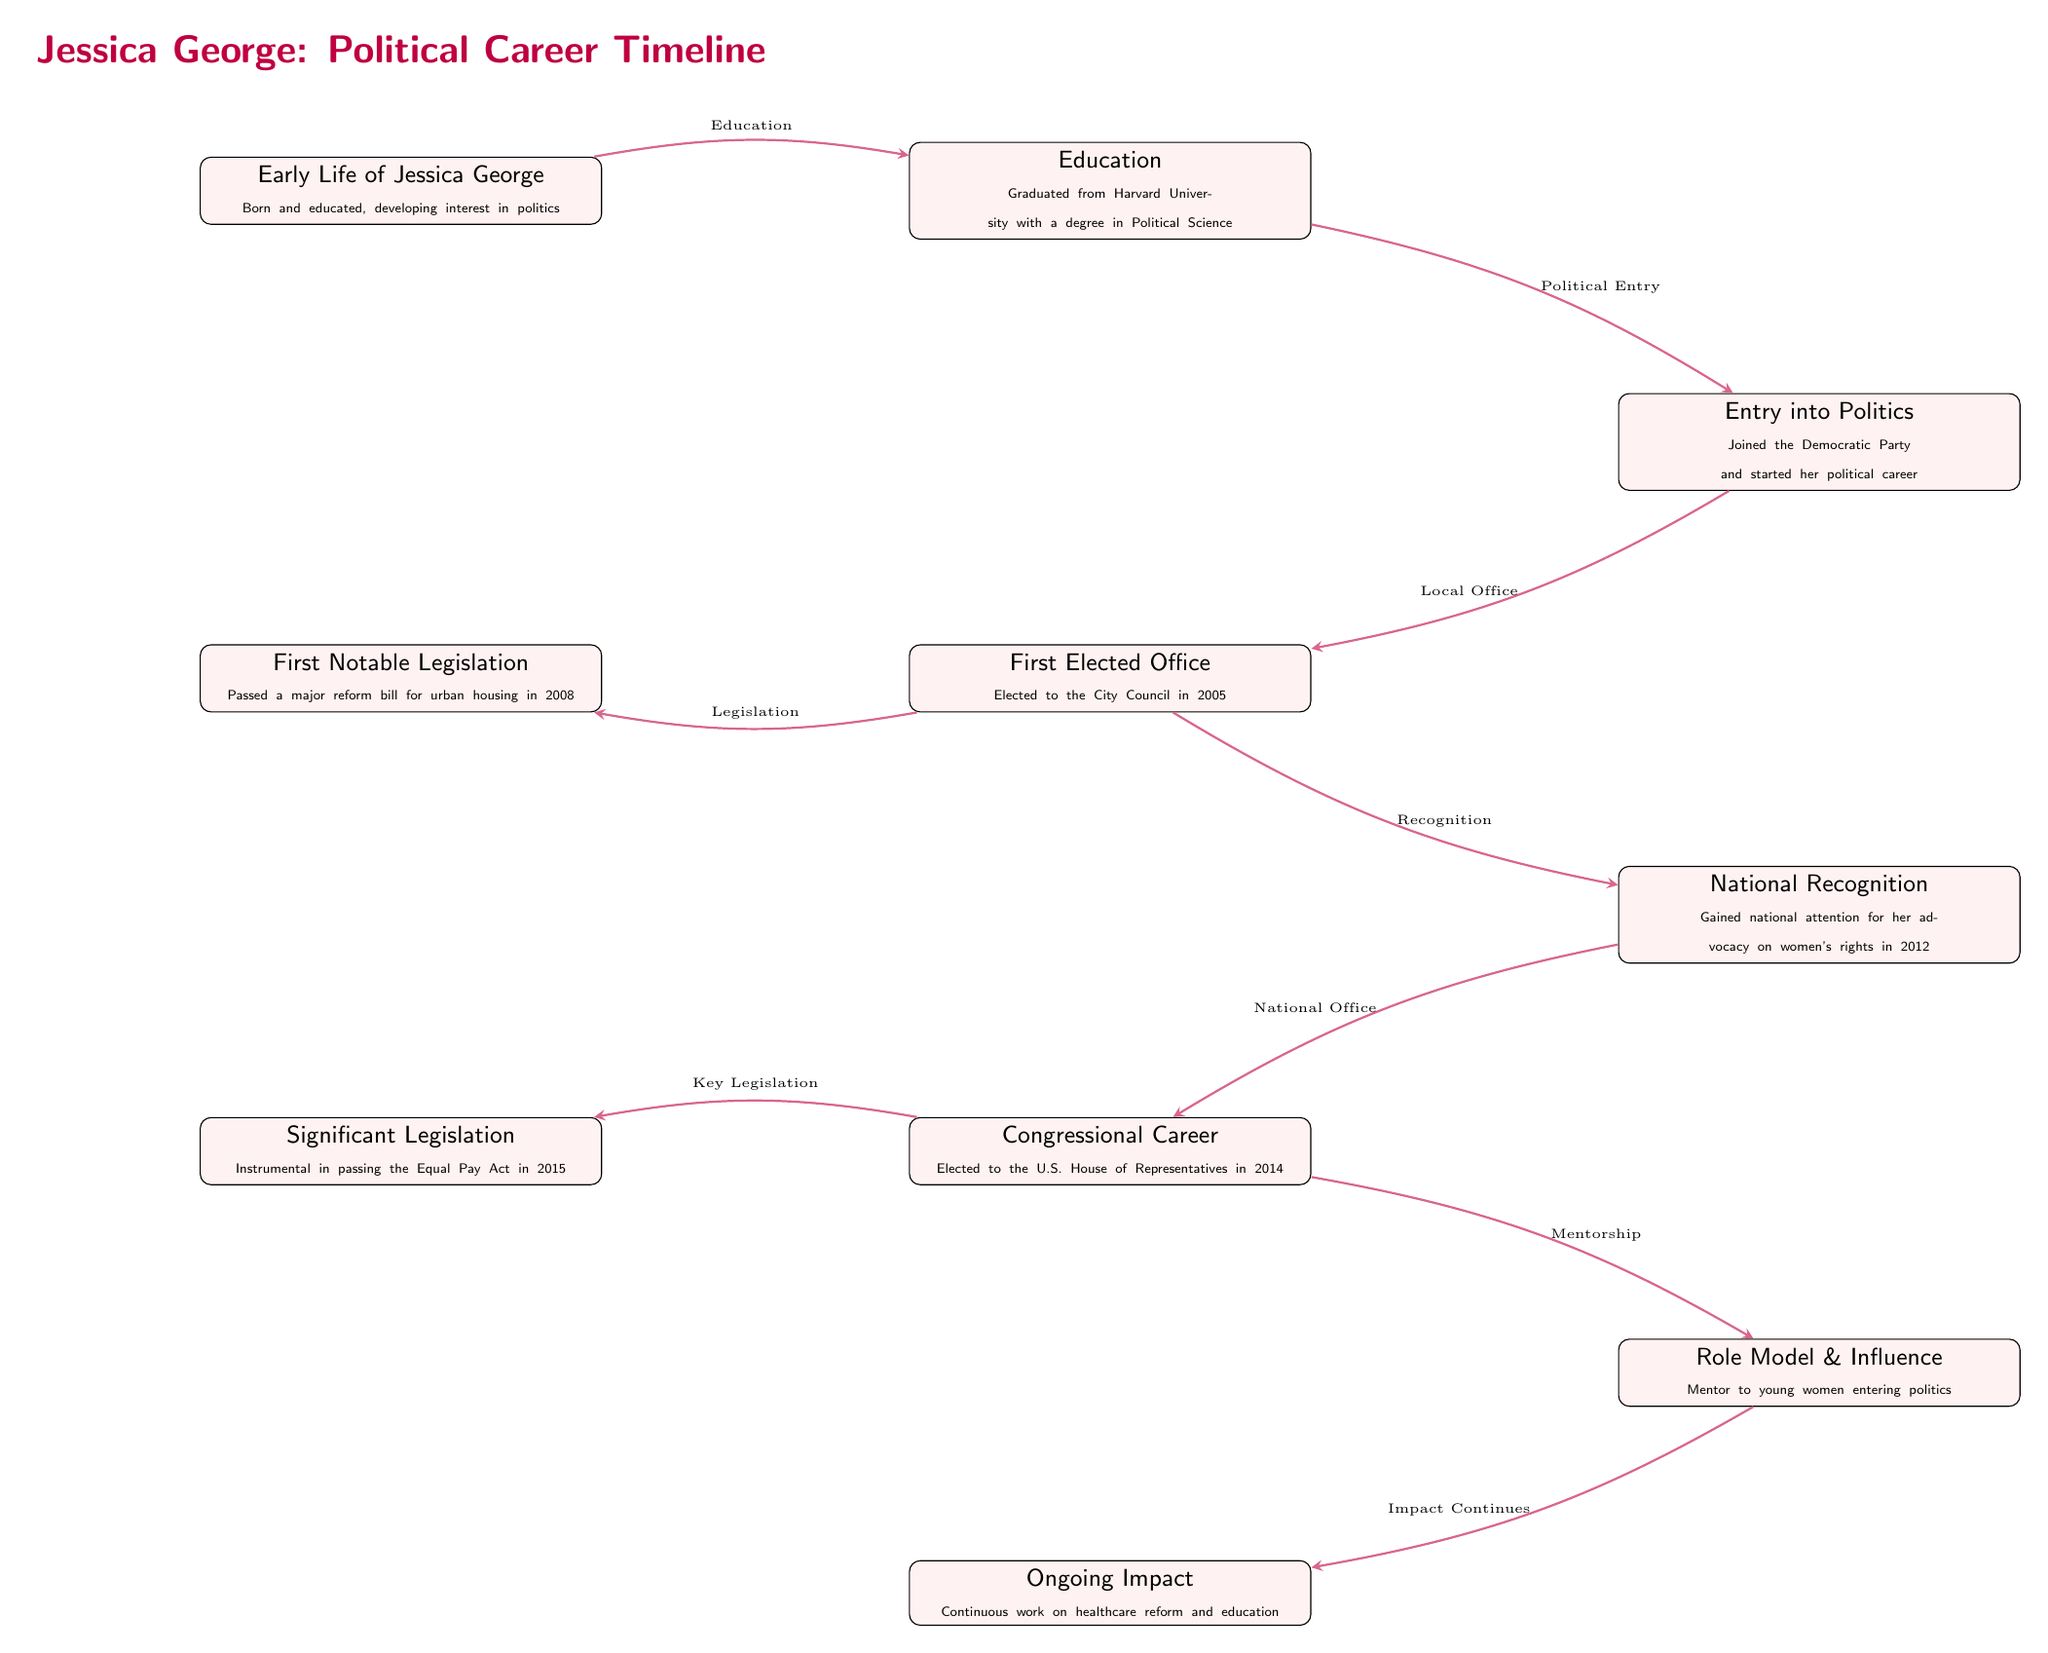What is the first notable legislation Jessica George passed? The diagram indicates that Jessica George passed a major reform bill for urban housing in 2008 as her first notable legislation. By looking at the timeline, this event appears directly after her first elected office.
Answer: Major reform bill for urban housing In what year was Jessica George elected to the U.S. House of Representatives? The timeline shows that Jessica George was elected to the U.S. House of Representatives in 2014, which is noted directly as the event in the diagram.
Answer: 2014 What major recognition did Jessica George gain in 2012? According to the diagram, she gained national attention for her advocacy on women's rights in 2012. This information is clearly labeled in the relevant node on the timeline.
Answer: National attention for women's rights How many nodes are in the diagram? By counting the individual events presented in the diagram, there are a total of 10 nodes detailing Jessica George's political career timeline.
Answer: 10 What type of legislation was Jessica George instrumental in passing in 2015? Looking at the timeline, Jessica George was instrumental in passing the Equal Pay Act in 2015. This specific legislation is highlighted as a significant achievement in her congressional career.
Answer: Equal Pay Act What is the relationship between her first elected office and her first notable legislation? The relationship is that after being elected to the City Council in 2005, she passed her first notable legislation (the major reform bill for urban housing) in 2008. This sequential flow is shown by the arrows in the diagram connecting the events.
Answer: Local office to legislation What ongoing impact is Jessica George known for? The diagram states that her ongoing impact includes continuous work on healthcare reform and education, which is a culmination of her later career efforts.
Answer: Healthcare reform and education Which event directly follows Jessica George's national recognition? The event that directly follows her gaining national recognition for her advocacy on women's rights in 2012 is her election to the U.S. House of Representatives in 2014. This can be identified by examining the arrows connecting the nodes in the diagram.
Answer: Congressional Career What does the node regarding mentorship indicate about Jessica George? The mentorship node signifies that Jessica George is a mentor to young women entering politics, emphasizing her role as a role model and influence in the political landscape.
Answer: Mentor to young women 